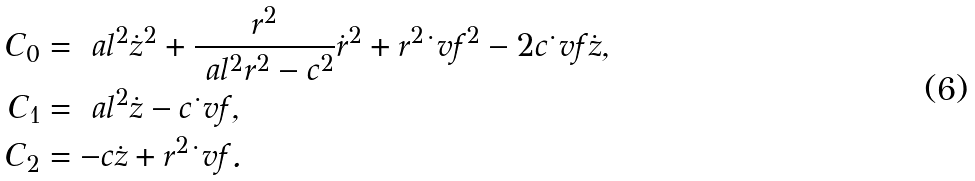<formula> <loc_0><loc_0><loc_500><loc_500>C _ { 0 } & = \ a l ^ { 2 } \dot { z } ^ { 2 } + \frac { r ^ { 2 } } { \ a l ^ { 2 } r ^ { 2 } - c ^ { 2 } } \dot { r } ^ { 2 } + r ^ { 2 } \dot { \ } v f ^ { 2 } - 2 c \dot { \ } v f \dot { z } , \\ C _ { 1 } & = \ a l ^ { 2 } \dot { z } - c \dot { \ } v f , \\ C _ { 2 } & = - c \dot { z } + r ^ { 2 } \dot { \ } v f .</formula> 